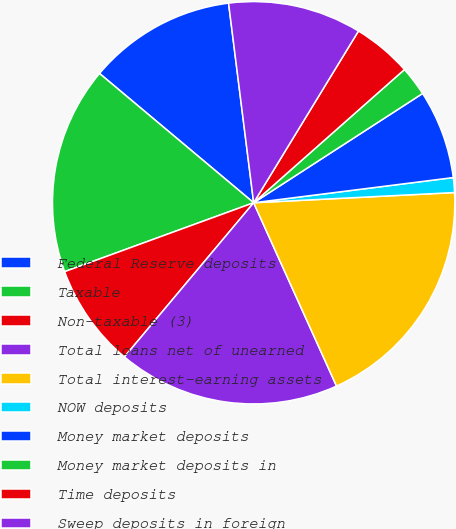<chart> <loc_0><loc_0><loc_500><loc_500><pie_chart><fcel>Federal Reserve deposits<fcel>Taxable<fcel>Non-taxable (3)<fcel>Total loans net of unearned<fcel>Total interest-earning assets<fcel>NOW deposits<fcel>Money market deposits<fcel>Money market deposits in<fcel>Time deposits<fcel>Sweep deposits in foreign<nl><fcel>11.9%<fcel>16.67%<fcel>8.33%<fcel>17.86%<fcel>19.05%<fcel>1.19%<fcel>7.14%<fcel>2.38%<fcel>4.76%<fcel>10.71%<nl></chart> 